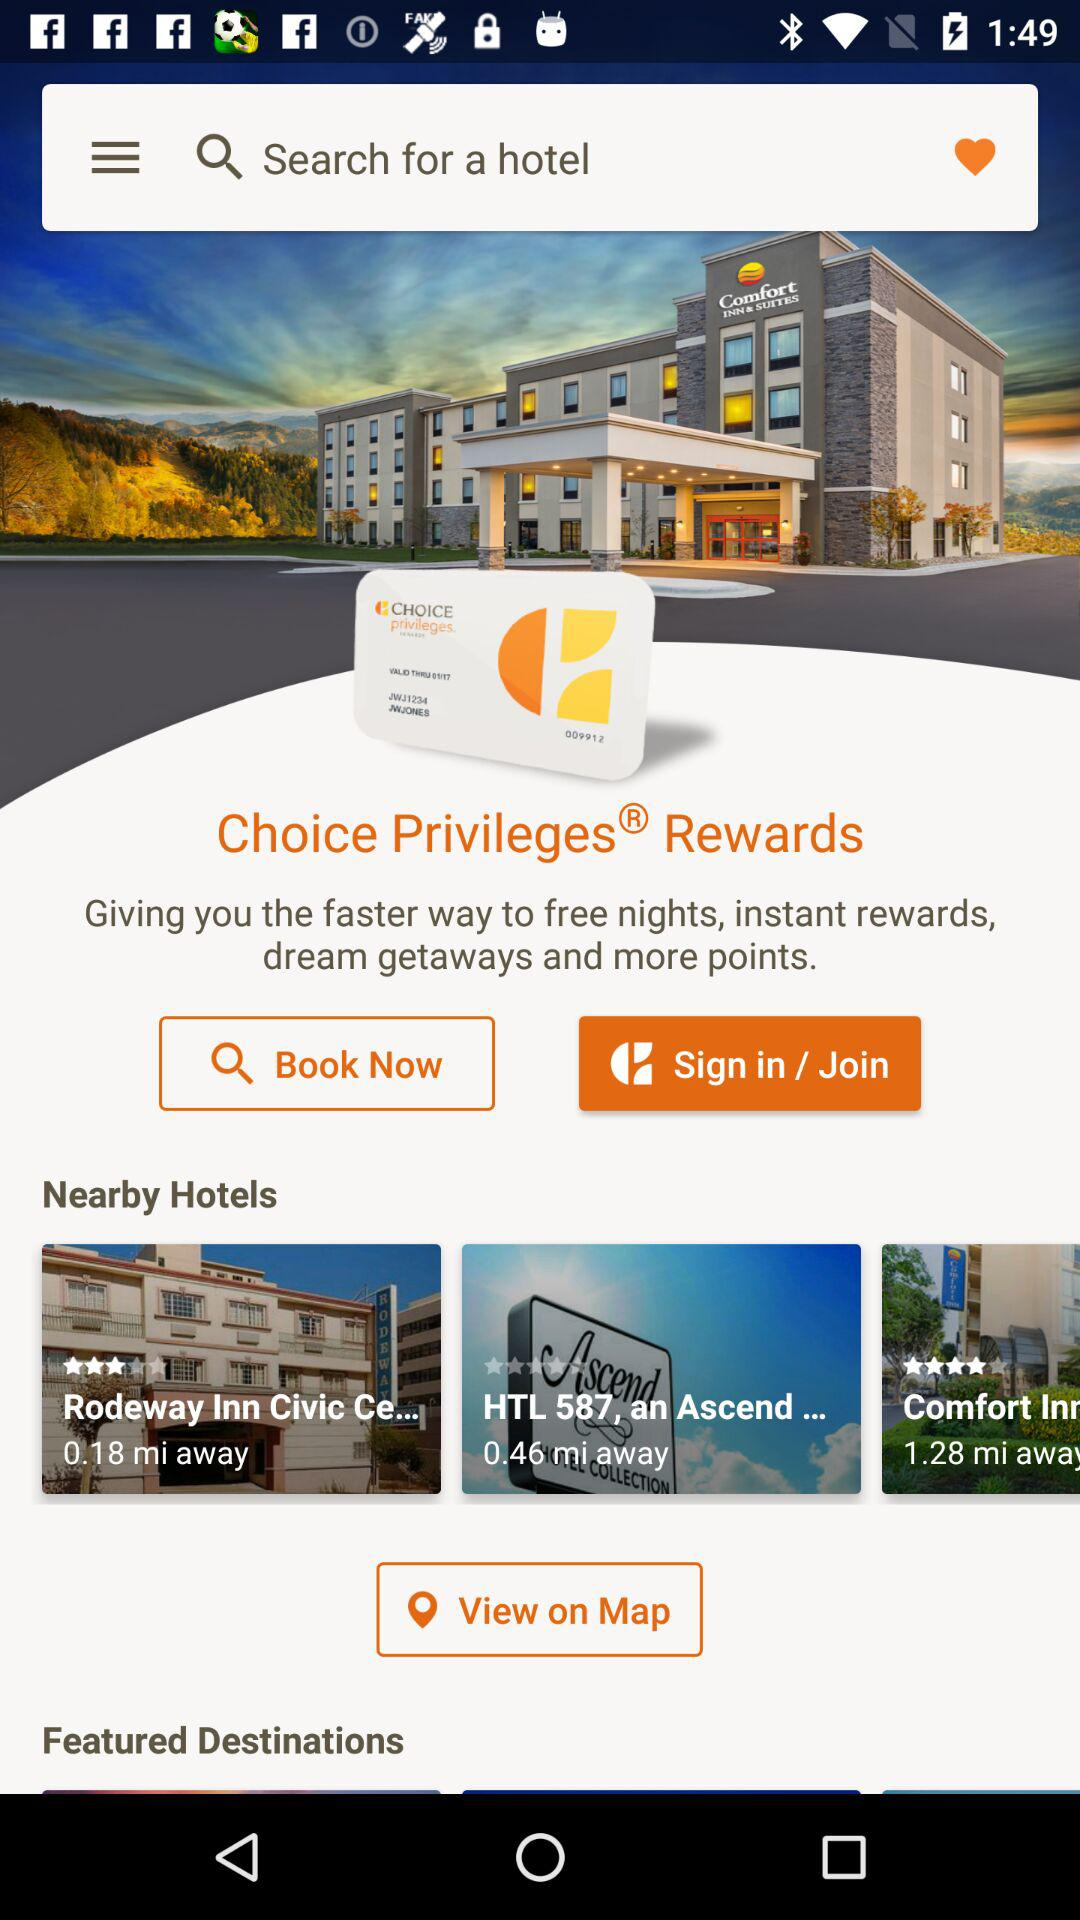How far away is the "Rodeway Inn" hotel? The hotel "Rodeway Inn" is 0.18 miles away. 